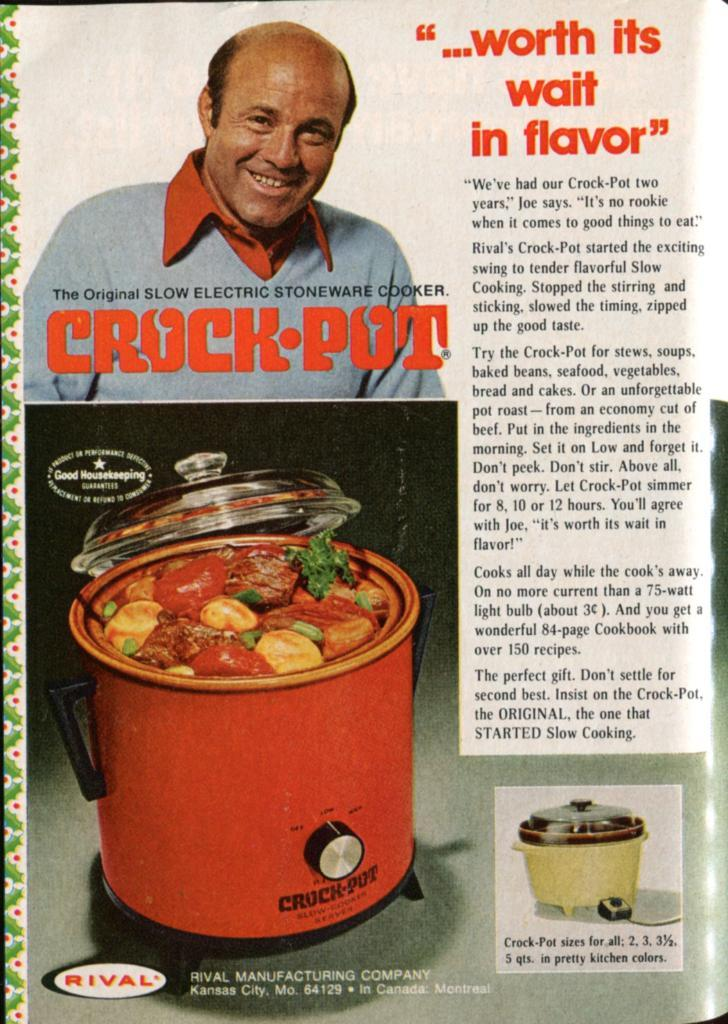What is the main subject of the image? There is a picture of a person in the image. What else can be seen in the image besides the person? There is an article and a cooker in the image. Where are these elements located? All elements are present on a magazine paper. What type of lace can be seen on the cooker in the image? There is no lace present on the cooker in the image. How does the earth contribute to the comfort of the person in the image? The image does not depict the earth or any elements related to comfort for the person. 